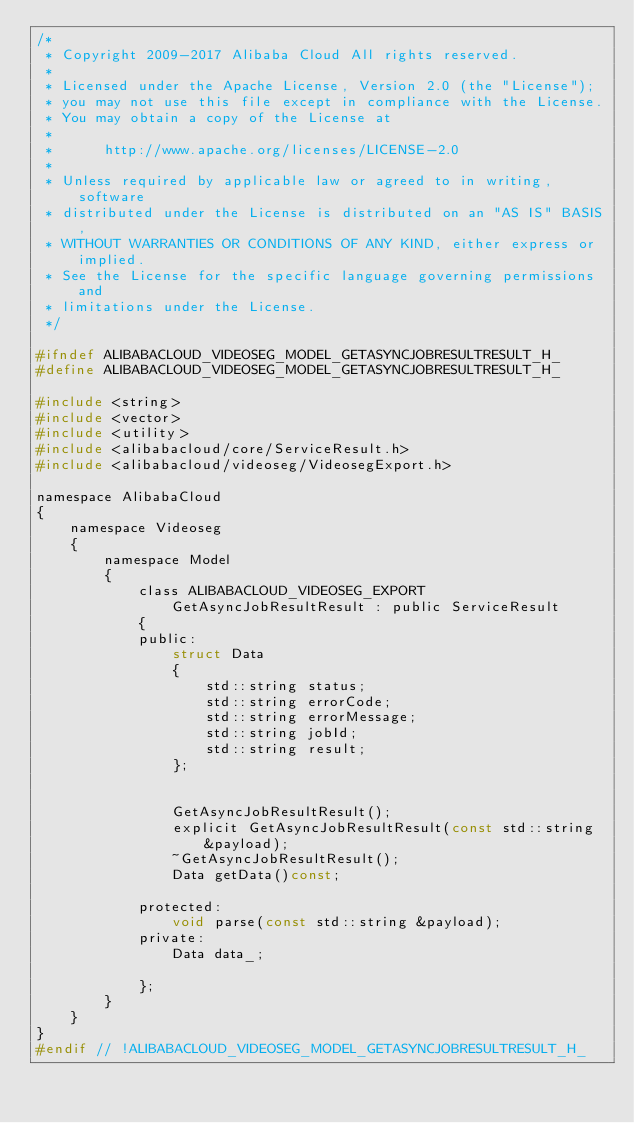<code> <loc_0><loc_0><loc_500><loc_500><_C_>/*
 * Copyright 2009-2017 Alibaba Cloud All rights reserved.
 * 
 * Licensed under the Apache License, Version 2.0 (the "License");
 * you may not use this file except in compliance with the License.
 * You may obtain a copy of the License at
 * 
 *      http://www.apache.org/licenses/LICENSE-2.0
 * 
 * Unless required by applicable law or agreed to in writing, software
 * distributed under the License is distributed on an "AS IS" BASIS,
 * WITHOUT WARRANTIES OR CONDITIONS OF ANY KIND, either express or implied.
 * See the License for the specific language governing permissions and
 * limitations under the License.
 */

#ifndef ALIBABACLOUD_VIDEOSEG_MODEL_GETASYNCJOBRESULTRESULT_H_
#define ALIBABACLOUD_VIDEOSEG_MODEL_GETASYNCJOBRESULTRESULT_H_

#include <string>
#include <vector>
#include <utility>
#include <alibabacloud/core/ServiceResult.h>
#include <alibabacloud/videoseg/VideosegExport.h>

namespace AlibabaCloud
{
	namespace Videoseg
	{
		namespace Model
		{
			class ALIBABACLOUD_VIDEOSEG_EXPORT GetAsyncJobResultResult : public ServiceResult
			{
			public:
				struct Data
				{
					std::string status;
					std::string errorCode;
					std::string errorMessage;
					std::string jobId;
					std::string result;
				};


				GetAsyncJobResultResult();
				explicit GetAsyncJobResultResult(const std::string &payload);
				~GetAsyncJobResultResult();
				Data getData()const;

			protected:
				void parse(const std::string &payload);
			private:
				Data data_;

			};
		}
	}
}
#endif // !ALIBABACLOUD_VIDEOSEG_MODEL_GETASYNCJOBRESULTRESULT_H_</code> 